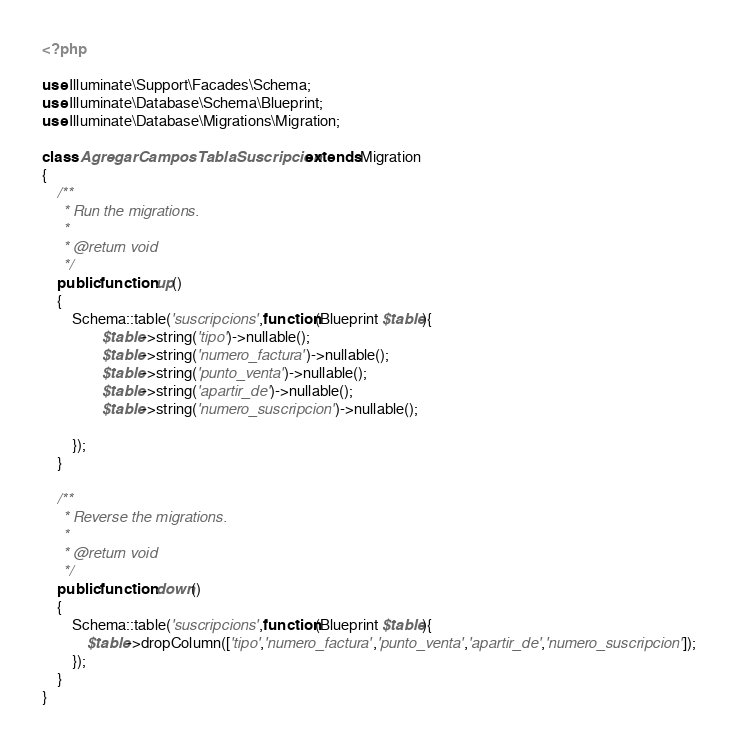Convert code to text. <code><loc_0><loc_0><loc_500><loc_500><_PHP_><?php

use Illuminate\Support\Facades\Schema;
use Illuminate\Database\Schema\Blueprint;
use Illuminate\Database\Migrations\Migration;

class AgregarCamposTablaSuscripcion extends Migration
{
    /**
     * Run the migrations.
     *
     * @return void
     */
    public function up()
    {
        Schema::table('suscripcions',function(Blueprint $table){
                $table->string('tipo')->nullable();
                $table->string('numero_factura')->nullable();
                $table->string('punto_venta')->nullable();
                $table->string('apartir_de')->nullable();
                $table->string('numero_suscripcion')->nullable();

        });
    }

    /**
     * Reverse the migrations.
     *
     * @return void
     */
    public function down()
    {
        Schema::table('suscripcions',function(Blueprint $table){
            $table->dropColumn(['tipo','numero_factura','punto_venta','apartir_de','numero_suscripcion']);
        });
    }
}
</code> 